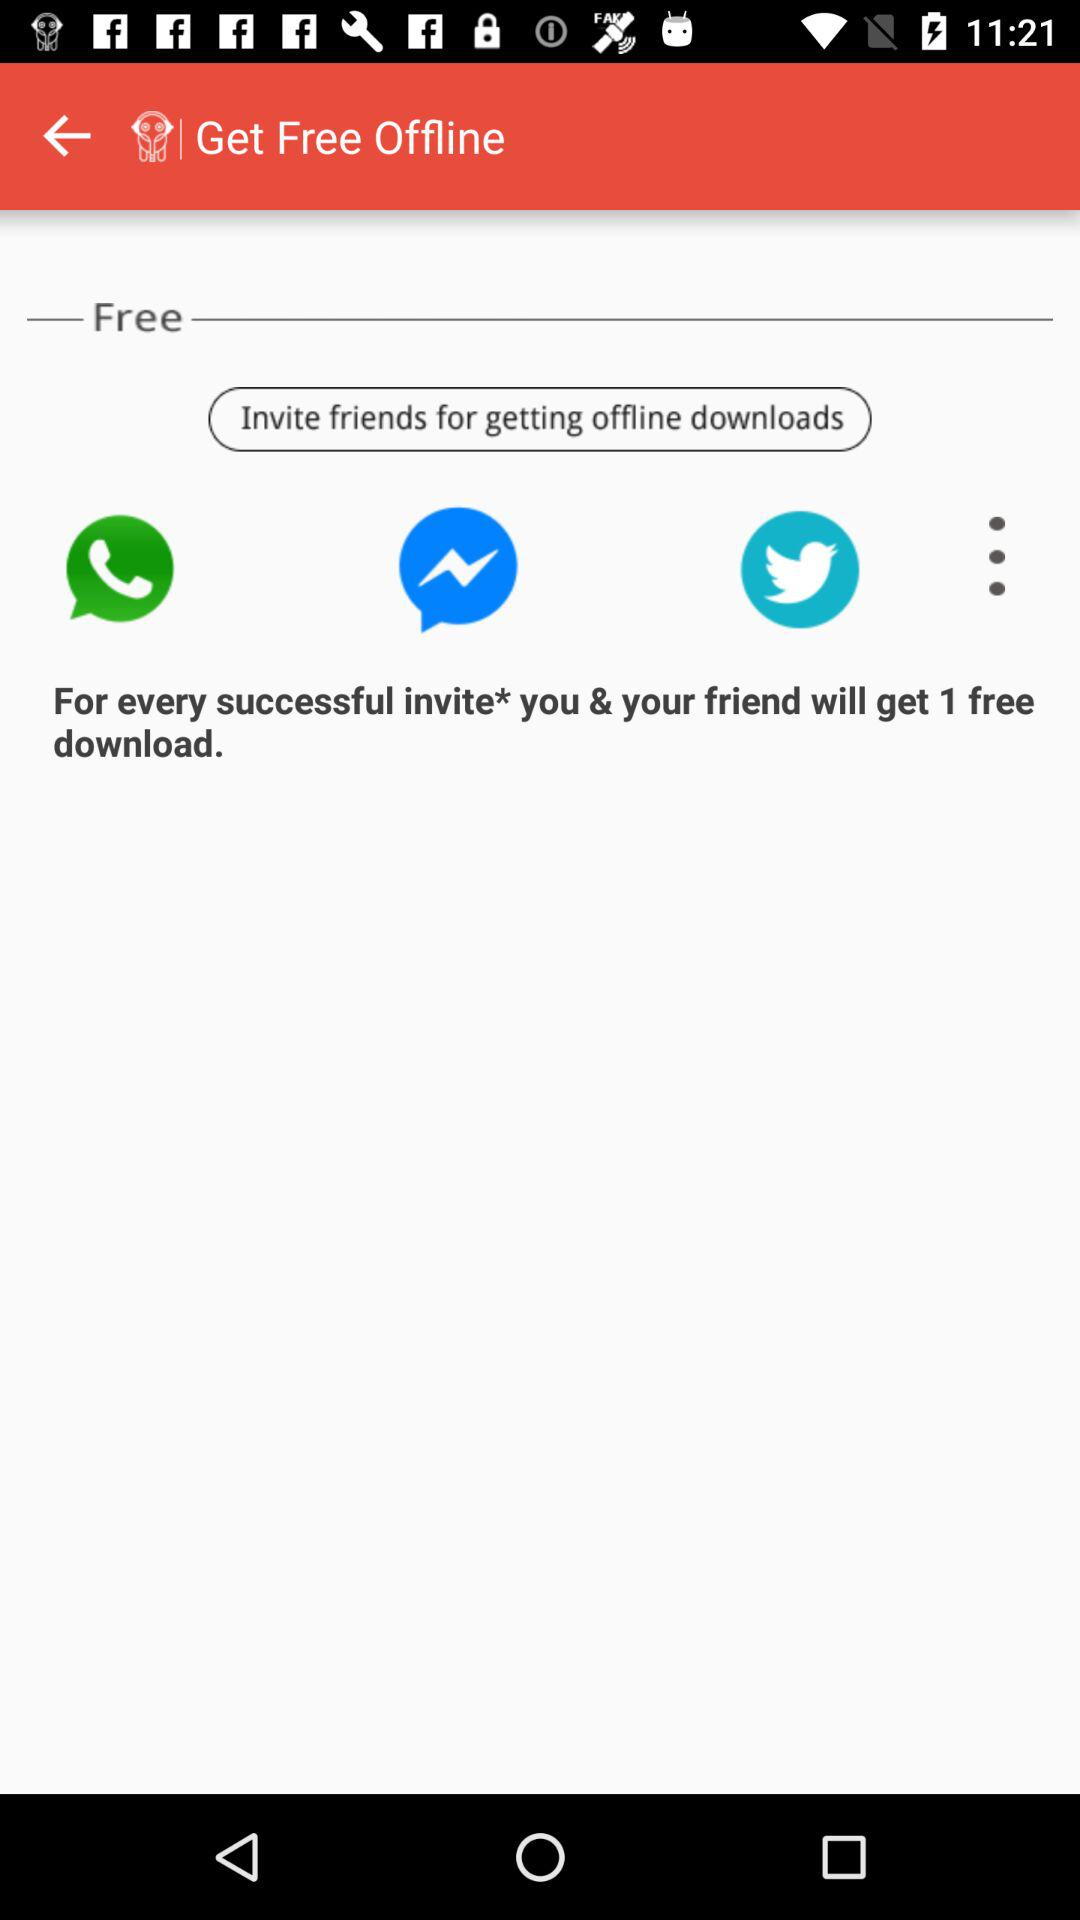How many downloads can you get for every friend you invite?
Answer the question using a single word or phrase. 1 